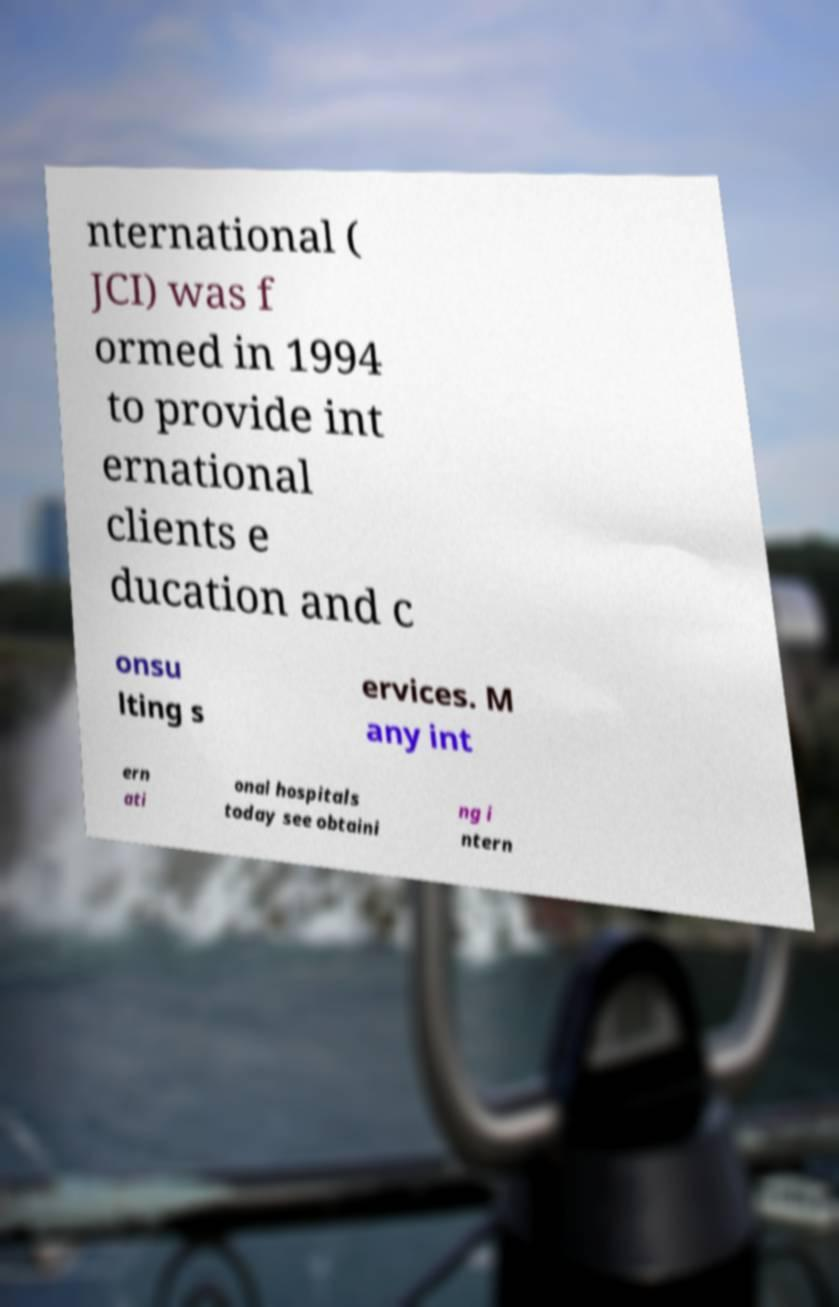For documentation purposes, I need the text within this image transcribed. Could you provide that? nternational ( JCI) was f ormed in 1994 to provide int ernational clients e ducation and c onsu lting s ervices. M any int ern ati onal hospitals today see obtaini ng i ntern 